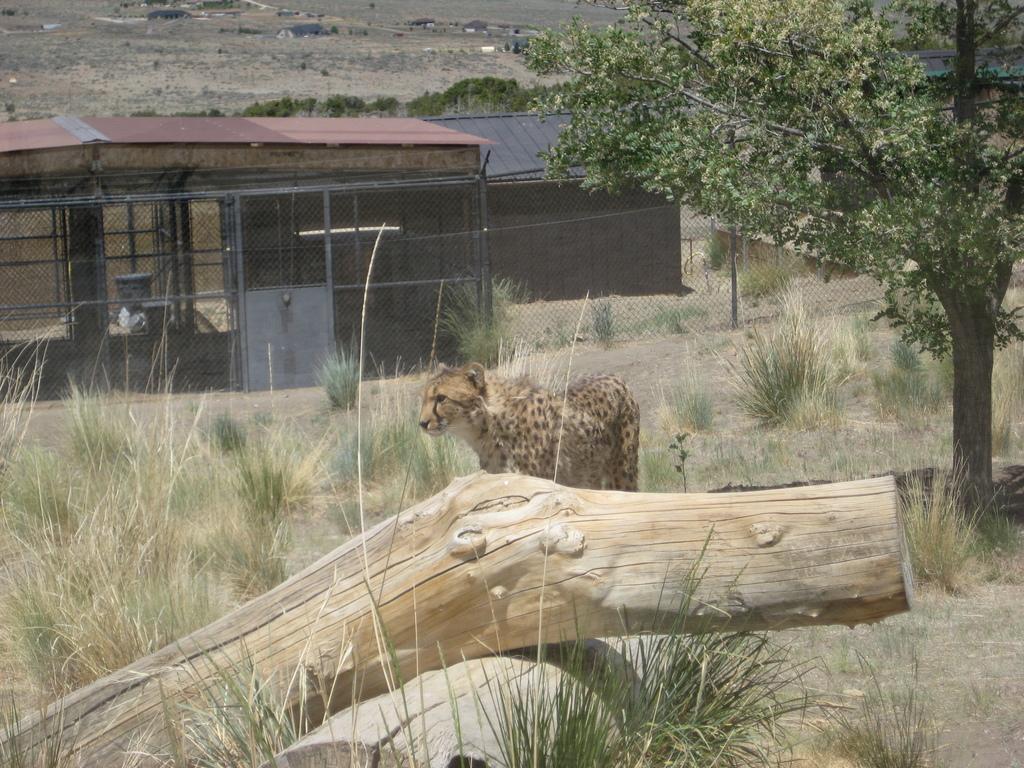How would you summarize this image in a sentence or two? In this image in the center there is one Leopard, and at the bottom there is grass and some wooden sticks. In the background there is a house, light and fence on the right side there is one tree and on the top of the image there is sand and some trees and houses. 